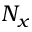Convert formula to latex. <formula><loc_0><loc_0><loc_500><loc_500>N _ { x }</formula> 